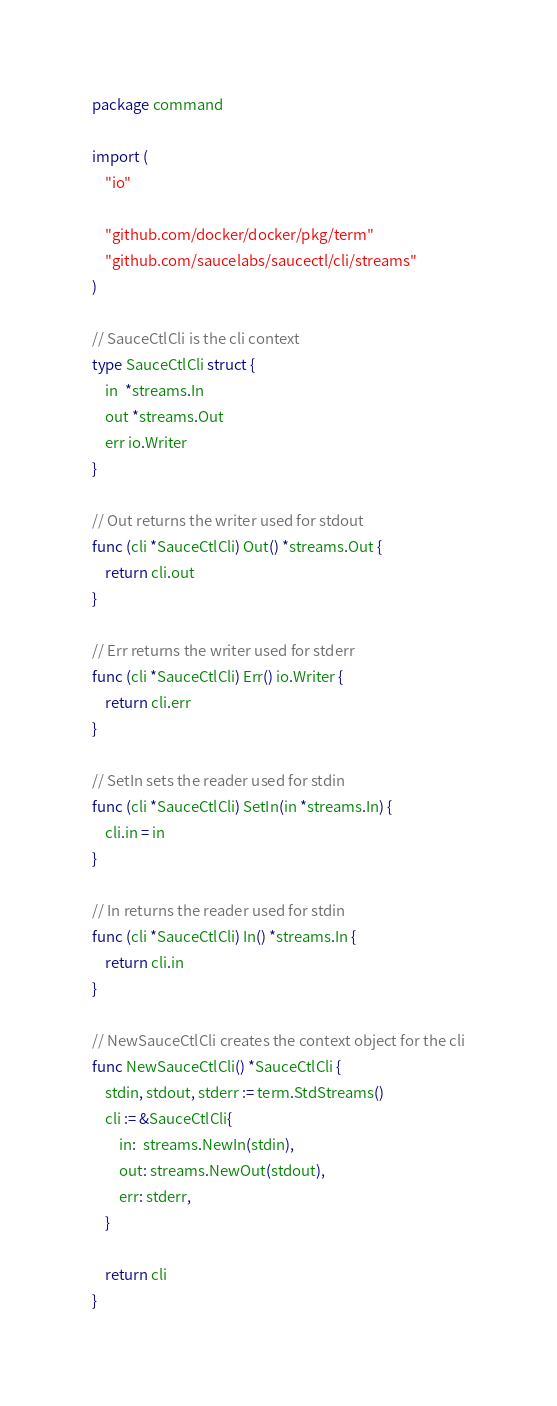<code> <loc_0><loc_0><loc_500><loc_500><_Go_>package command

import (
	"io"

	"github.com/docker/docker/pkg/term"
	"github.com/saucelabs/saucectl/cli/streams"
)

// SauceCtlCli is the cli context
type SauceCtlCli struct {
	in  *streams.In
	out *streams.Out
	err io.Writer
}

// Out returns the writer used for stdout
func (cli *SauceCtlCli) Out() *streams.Out {
	return cli.out
}

// Err returns the writer used for stderr
func (cli *SauceCtlCli) Err() io.Writer {
	return cli.err
}

// SetIn sets the reader used for stdin
func (cli *SauceCtlCli) SetIn(in *streams.In) {
	cli.in = in
}

// In returns the reader used for stdin
func (cli *SauceCtlCli) In() *streams.In {
	return cli.in
}

// NewSauceCtlCli creates the context object for the cli
func NewSauceCtlCli() *SauceCtlCli {
	stdin, stdout, stderr := term.StdStreams()
	cli := &SauceCtlCli{
		in:  streams.NewIn(stdin),
		out: streams.NewOut(stdout),
		err: stderr,
	}

	return cli
}
</code> 